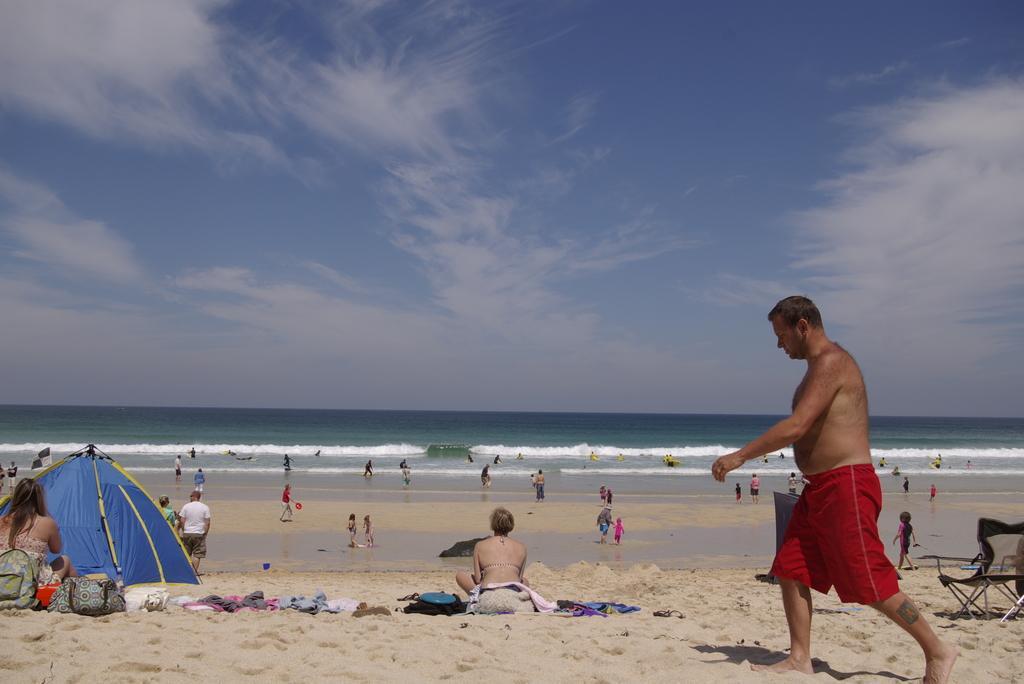How would you summarize this image in a sentence or two? In this image I can see a person walking and the person is wearing red color short. Background I can see few persons some are sitting and some are standing, a tent in blue color, I can also see the water, and the sky is in white and blue color. 